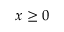<formula> <loc_0><loc_0><loc_500><loc_500>x \geq 0</formula> 